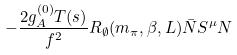<formula> <loc_0><loc_0><loc_500><loc_500>- \frac { 2 g _ { A } ^ { ( 0 ) } T ( s ) } { f ^ { 2 } } R _ { \emptyset } ( m _ { \pi } , \beta , L ) \bar { N } S ^ { \mu } N \\</formula> 